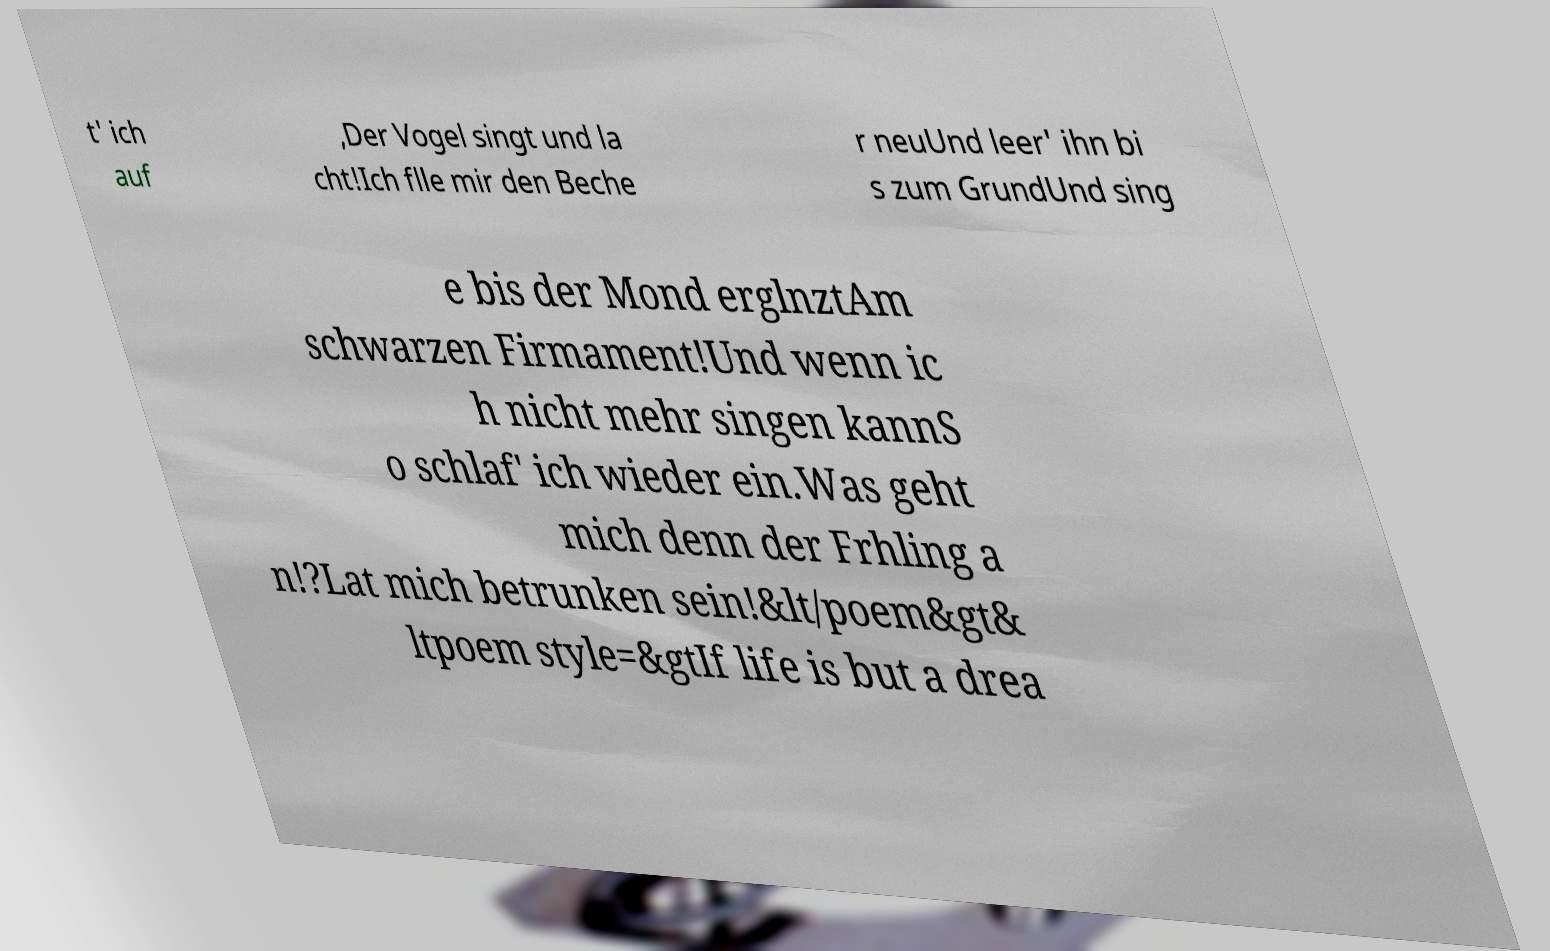Can you accurately transcribe the text from the provided image for me? t' ich auf ,Der Vogel singt und la cht!Ich flle mir den Beche r neuUnd leer' ihn bi s zum GrundUnd sing e bis der Mond erglnztAm schwarzen Firmament!Und wenn ic h nicht mehr singen kannS o schlaf' ich wieder ein.Was geht mich denn der Frhling a n!?Lat mich betrunken sein!&lt/poem&gt& ltpoem style=&gtIf life is but a drea 